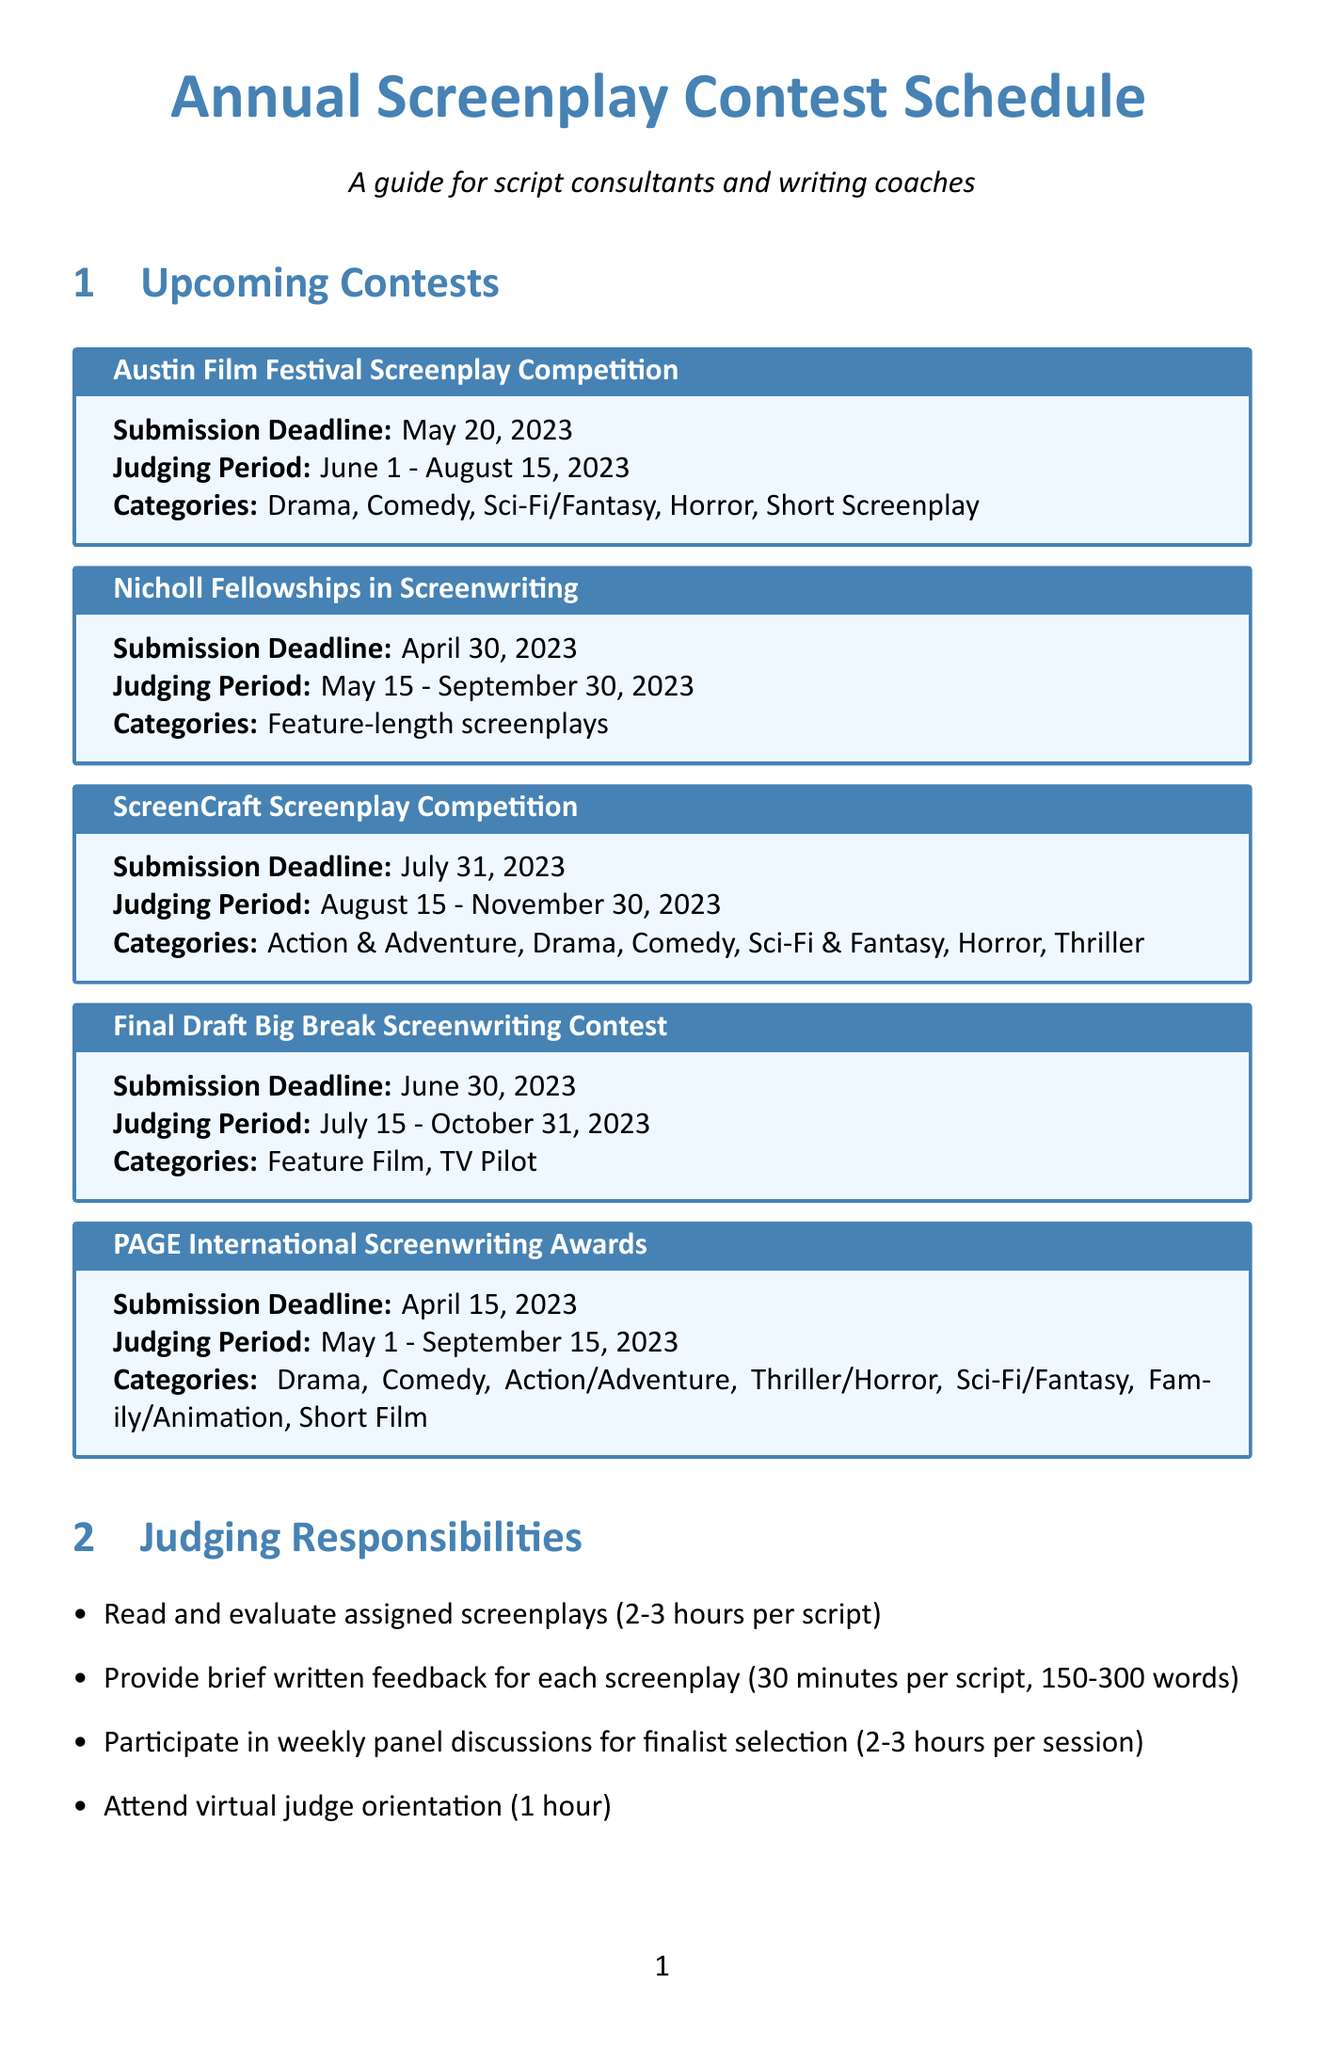What is the submission deadline for the Nicholl Fellowships in Screenwriting? The submission deadline for the Nicholl Fellowships in Screenwriting is April 30, 2023, as listed in the document.
Answer: April 30, 2023 What is the duration of the judging period for the PAGE International Screenwriting Awards? The judging period for the PAGE International Screenwriting Awards is from May 1 to September 15, 2023, as stated in the document.
Answer: May 1 - September 15, 2023 What is one of the evaluation criteria for the Austin Film Festival Screenplay Competition? One of the evaluation criteria listed for the Austin Film Festival Screenplay Competition is "Originality," which is mentioned in the evaluation criteria section.
Answer: Originality How long is the judging period for the ScreenCraft Screenplay Competition? The judging period for the ScreenCraft Screenplay Competition is August 15 to November 30, 2023, as indicated in the document.
Answer: August 15 - November 30, 2023 What is the frequency of panel discussions during the finalist selection phase? The document mentions that the panel discussions for finalist selection occur weekly during the final judging phase.
Answer: Weekly How long should the written feedback for each screenplay be? The document specifies that feedback should be between 150 to 300 words per screenplay.
Answer: 150-300 words What should a compelling logline highlight according to the industry insights? The industry insights suggest a compelling logline should highlight the unique concept.
Answer: Unique concept In how many categories does the PAGE International Screenwriting Awards accept entries? The document lists seven categories for the PAGE International Screenwriting Awards.
Answer: Seven What is the estimated time per script for reading and evaluating? The estimated time per script for reading and evaluating is between 2 to 3 hours, as mentioned in the judging responsibilities section.
Answer: 2-3 hours 